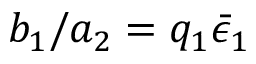Convert formula to latex. <formula><loc_0><loc_0><loc_500><loc_500>b _ { 1 } / a _ { 2 } = q _ { 1 } \bar { \epsilon } _ { 1 }</formula> 